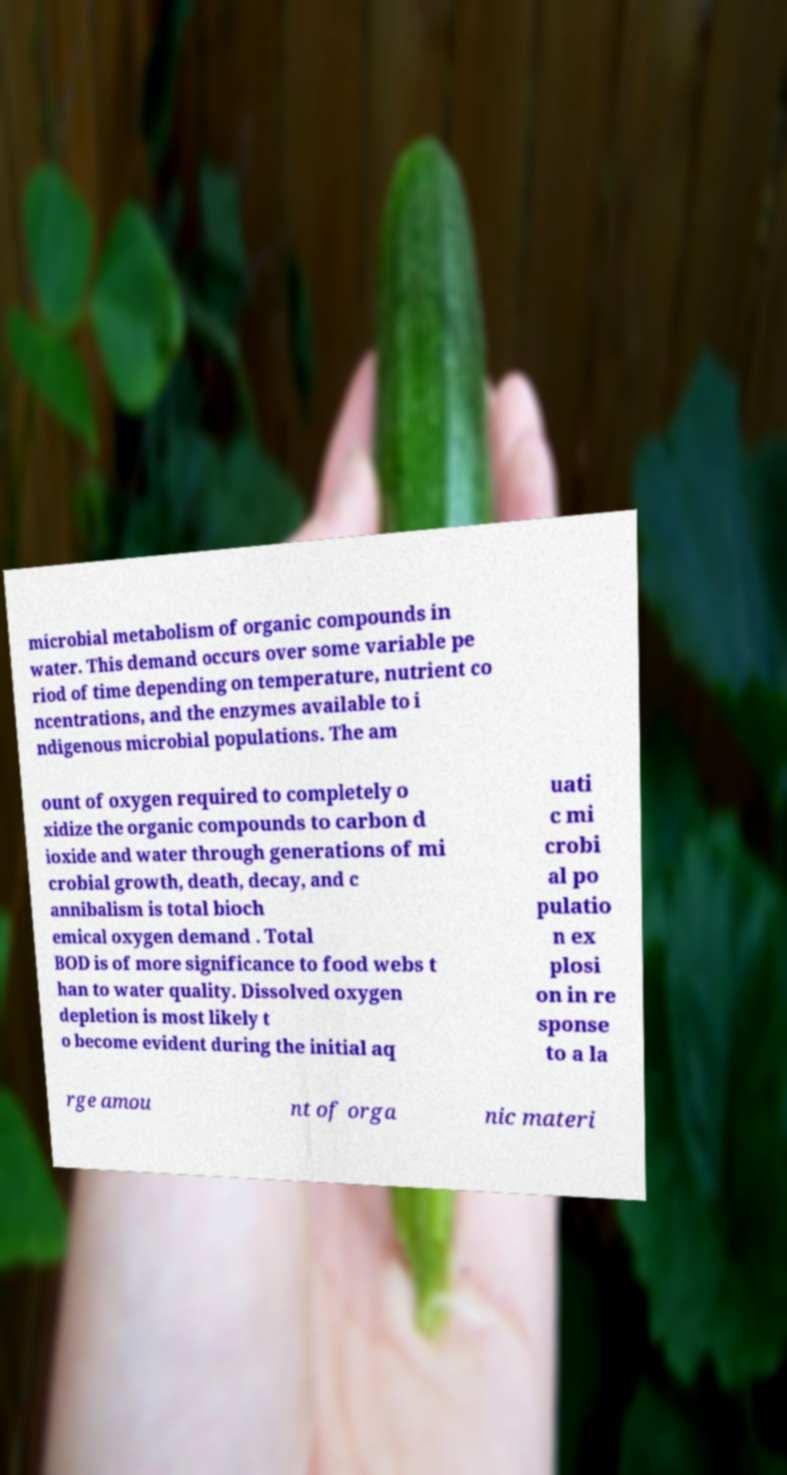There's text embedded in this image that I need extracted. Can you transcribe it verbatim? microbial metabolism of organic compounds in water. This demand occurs over some variable pe riod of time depending on temperature, nutrient co ncentrations, and the enzymes available to i ndigenous microbial populations. The am ount of oxygen required to completely o xidize the organic compounds to carbon d ioxide and water through generations of mi crobial growth, death, decay, and c annibalism is total bioch emical oxygen demand . Total BOD is of more significance to food webs t han to water quality. Dissolved oxygen depletion is most likely t o become evident during the initial aq uati c mi crobi al po pulatio n ex plosi on in re sponse to a la rge amou nt of orga nic materi 